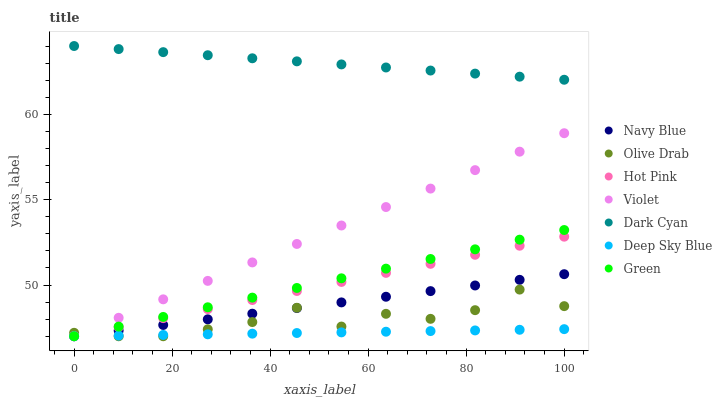Does Deep Sky Blue have the minimum area under the curve?
Answer yes or no. Yes. Does Dark Cyan have the maximum area under the curve?
Answer yes or no. Yes. Does Hot Pink have the minimum area under the curve?
Answer yes or no. No. Does Hot Pink have the maximum area under the curve?
Answer yes or no. No. Is Hot Pink the smoothest?
Answer yes or no. Yes. Is Olive Drab the roughest?
Answer yes or no. Yes. Is Green the smoothest?
Answer yes or no. No. Is Green the roughest?
Answer yes or no. No. Does Navy Blue have the lowest value?
Answer yes or no. Yes. Does Dark Cyan have the lowest value?
Answer yes or no. No. Does Dark Cyan have the highest value?
Answer yes or no. Yes. Does Hot Pink have the highest value?
Answer yes or no. No. Is Deep Sky Blue less than Dark Cyan?
Answer yes or no. Yes. Is Dark Cyan greater than Violet?
Answer yes or no. Yes. Does Navy Blue intersect Violet?
Answer yes or no. Yes. Is Navy Blue less than Violet?
Answer yes or no. No. Is Navy Blue greater than Violet?
Answer yes or no. No. Does Deep Sky Blue intersect Dark Cyan?
Answer yes or no. No. 